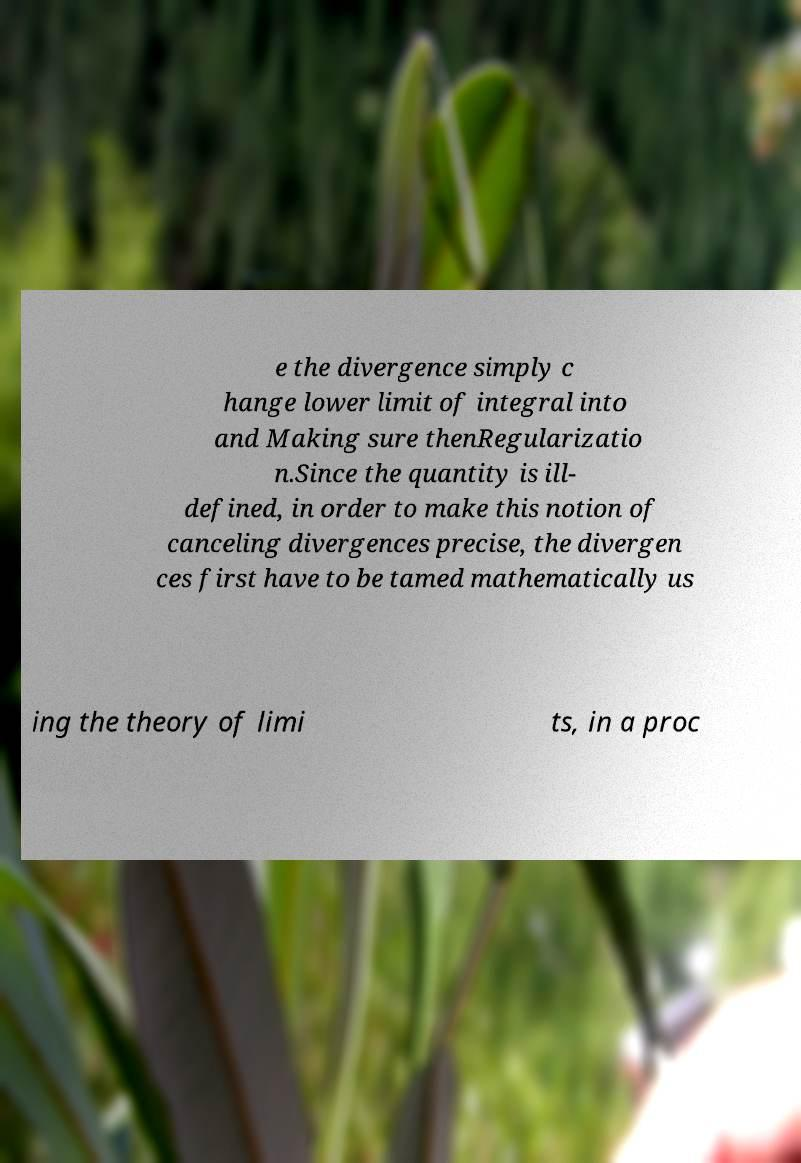For documentation purposes, I need the text within this image transcribed. Could you provide that? e the divergence simply c hange lower limit of integral into and Making sure thenRegularizatio n.Since the quantity is ill- defined, in order to make this notion of canceling divergences precise, the divergen ces first have to be tamed mathematically us ing the theory of limi ts, in a proc 